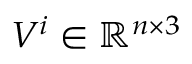Convert formula to latex. <formula><loc_0><loc_0><loc_500><loc_500>V ^ { i } \in \mathbb { R } ^ { n \times 3 }</formula> 